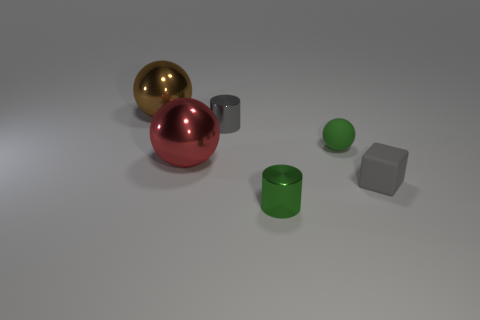Are there more tiny gray metallic cylinders than small purple metal cylinders?
Your response must be concise. Yes. What is the material of the small block?
Your answer should be compact. Rubber. There is a tiny green thing that is in front of the small gray matte thing; what number of tiny metallic cylinders are right of it?
Keep it short and to the point. 0. There is a block; is its color the same as the cylinder that is behind the small green rubber sphere?
Offer a terse response. Yes. There is another sphere that is the same size as the red shiny sphere; what is its color?
Your response must be concise. Brown. Are there any other shiny objects of the same shape as the big red metal thing?
Offer a terse response. Yes. Is the number of rubber blocks less than the number of tiny blue objects?
Make the answer very short. No. The cylinder that is in front of the small gray cylinder is what color?
Give a very brief answer. Green. What shape is the tiny object on the left side of the shiny cylinder in front of the gray shiny object?
Ensure brevity in your answer.  Cylinder. Do the red ball and the tiny cylinder behind the small cube have the same material?
Offer a terse response. Yes. 